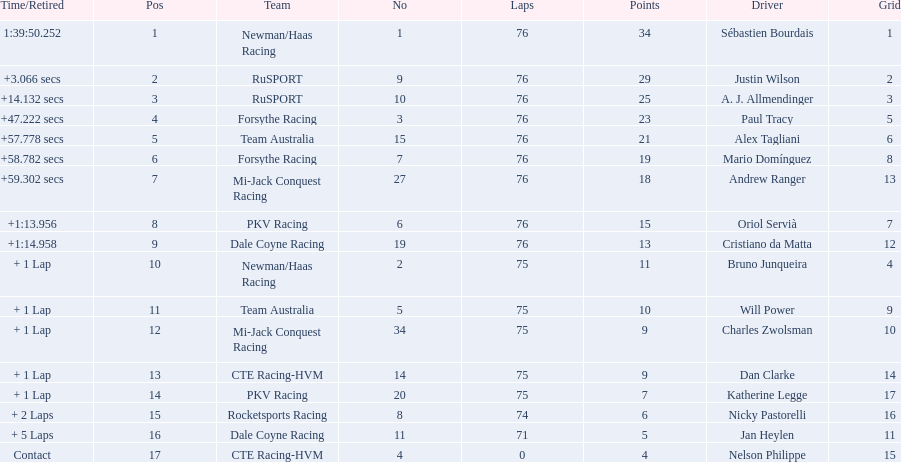How many points did charles zwolsman acquire? 9. Who else got 9 points? Dan Clarke. 